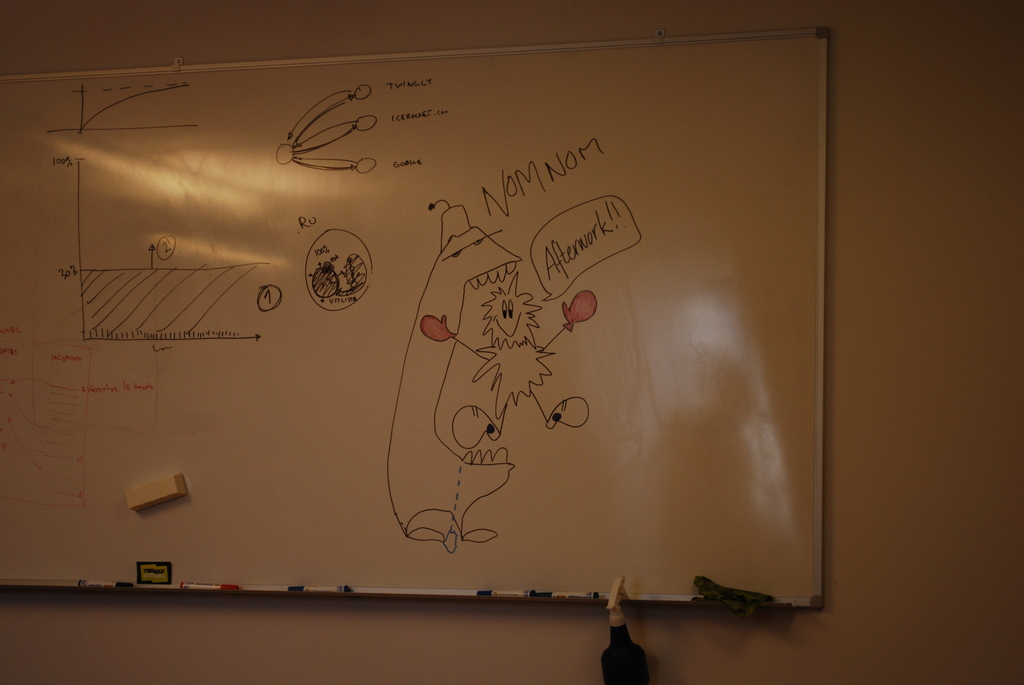Provide a one-sentence caption for the provided image.
Reference OCR token: TUINGLY, (CLoCC, NenNern, wwe, Aleark, MIKitt A dry erase board has a graph and a picture of a happy, fuzzy being saying, "Afterwork!" and labeled with the saying, "NOM NOM.". 